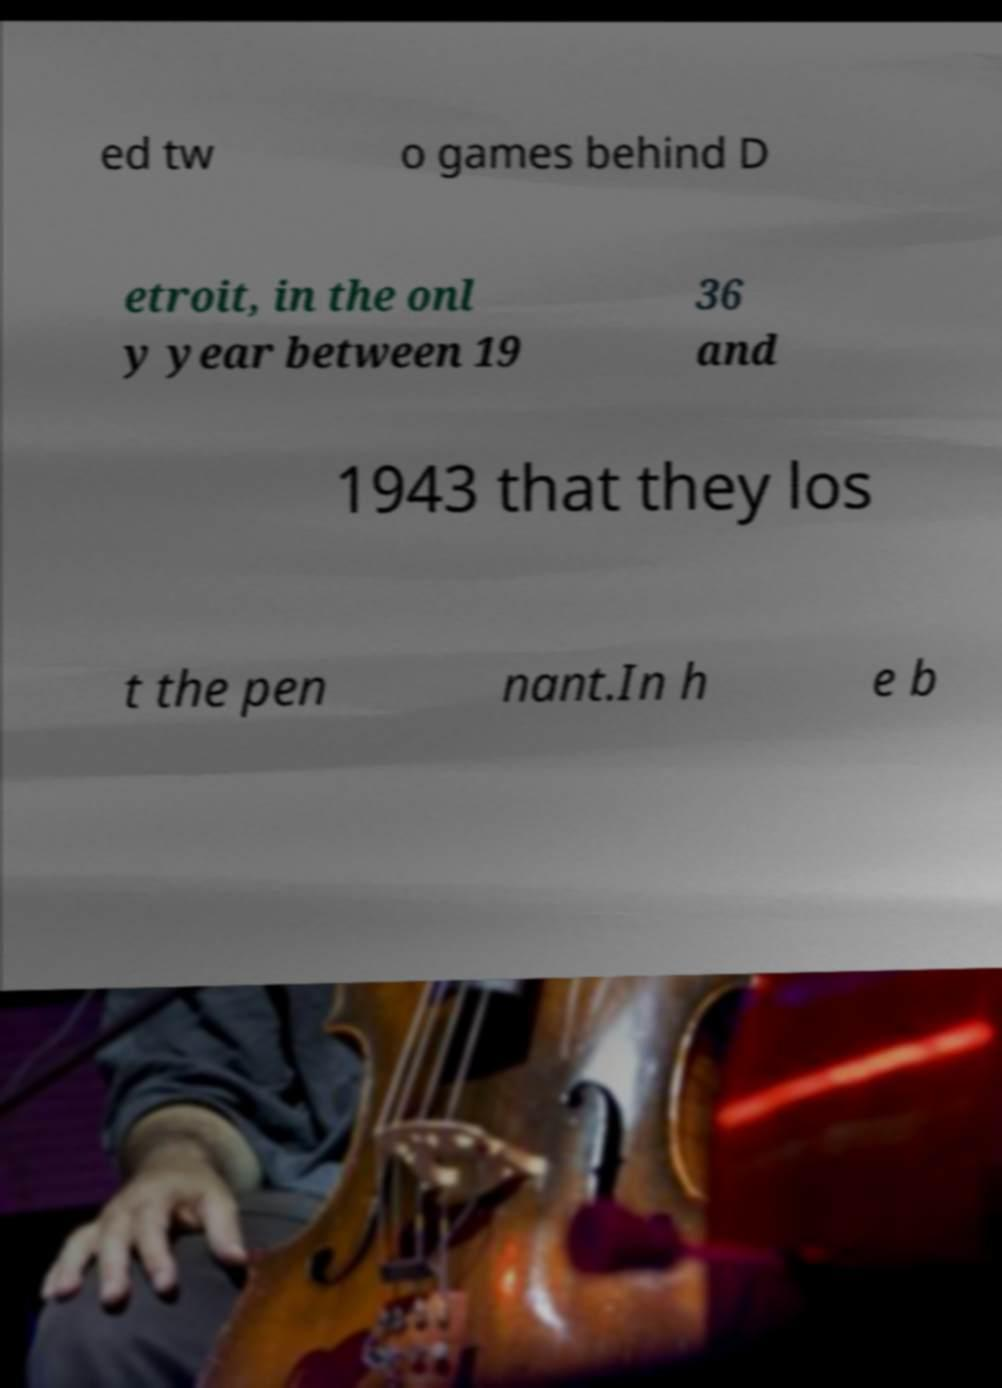Could you assist in decoding the text presented in this image and type it out clearly? ed tw o games behind D etroit, in the onl y year between 19 36 and 1943 that they los t the pen nant.In h e b 